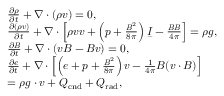<formula> <loc_0><loc_0><loc_500><loc_500>\begin{array} { r l } & { \frac { \partial \rho } { \partial t } + \nabla \cdot ( \rho v ) = 0 , } \\ & { \frac { \partial ( \rho v ) } { \partial t } + \nabla \cdot \left [ \rho v v + \left ( p + \frac { B ^ { 2 } } { 8 \pi } \right ) \underbar I - \frac { B B } { 4 \pi } \right ] = \rho g , } \\ & { \frac { \partial B } { \partial t } + \nabla \cdot ( v B - B v ) = 0 , } \\ & { \frac { \partial e } { \partial t } + \nabla \cdot \left [ \left ( e + p + \frac { B ^ { 2 } } { 8 \pi } \right ) v - \frac { 1 } { 4 \pi } B ( v \cdot B ) \right ] } \\ & { = \rho g \cdot v + Q _ { c n d } + Q _ { r a d } , } \end{array}</formula> 